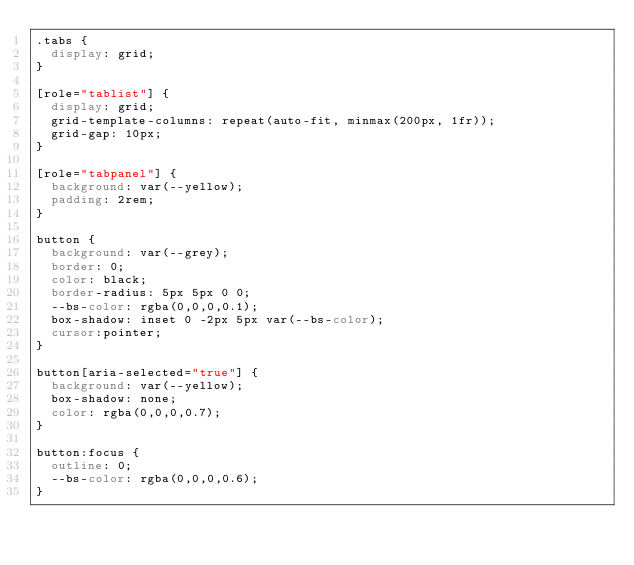<code> <loc_0><loc_0><loc_500><loc_500><_CSS_>.tabs {
  display: grid;
}

[role="tablist"] {
  display: grid;
  grid-template-columns: repeat(auto-fit, minmax(200px, 1fr));
  grid-gap: 10px;
}

[role="tabpanel"] {
  background: var(--yellow);
  padding: 2rem;
}

button {
  background: var(--grey);
  border: 0;
  color: black;
  border-radius: 5px 5px 0 0;
  --bs-color: rgba(0,0,0,0.1);
  box-shadow: inset 0 -2px 5px var(--bs-color);
  cursor:pointer;
}

button[aria-selected="true"] {
  background: var(--yellow);
  box-shadow: none;
  color: rgba(0,0,0,0.7);
}

button:focus {
  outline: 0;
  --bs-color: rgba(0,0,0,0.6);
}</code> 